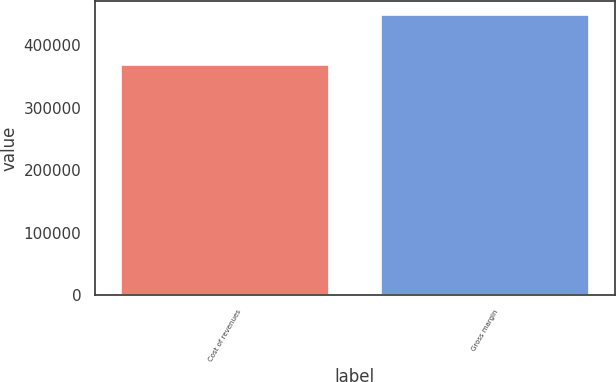Convert chart. <chart><loc_0><loc_0><loc_500><loc_500><bar_chart><fcel>Cost of revenues<fcel>Gross margin<nl><fcel>368576<fcel>447910<nl></chart> 